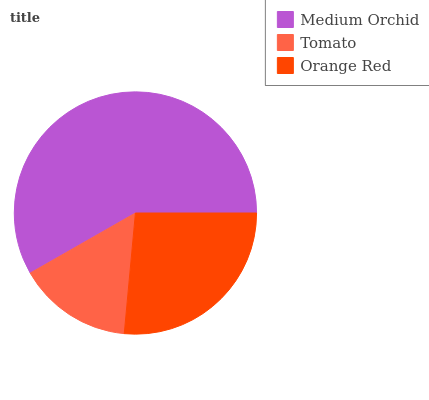Is Tomato the minimum?
Answer yes or no. Yes. Is Medium Orchid the maximum?
Answer yes or no. Yes. Is Orange Red the minimum?
Answer yes or no. No. Is Orange Red the maximum?
Answer yes or no. No. Is Orange Red greater than Tomato?
Answer yes or no. Yes. Is Tomato less than Orange Red?
Answer yes or no. Yes. Is Tomato greater than Orange Red?
Answer yes or no. No. Is Orange Red less than Tomato?
Answer yes or no. No. Is Orange Red the high median?
Answer yes or no. Yes. Is Orange Red the low median?
Answer yes or no. Yes. Is Medium Orchid the high median?
Answer yes or no. No. Is Tomato the low median?
Answer yes or no. No. 